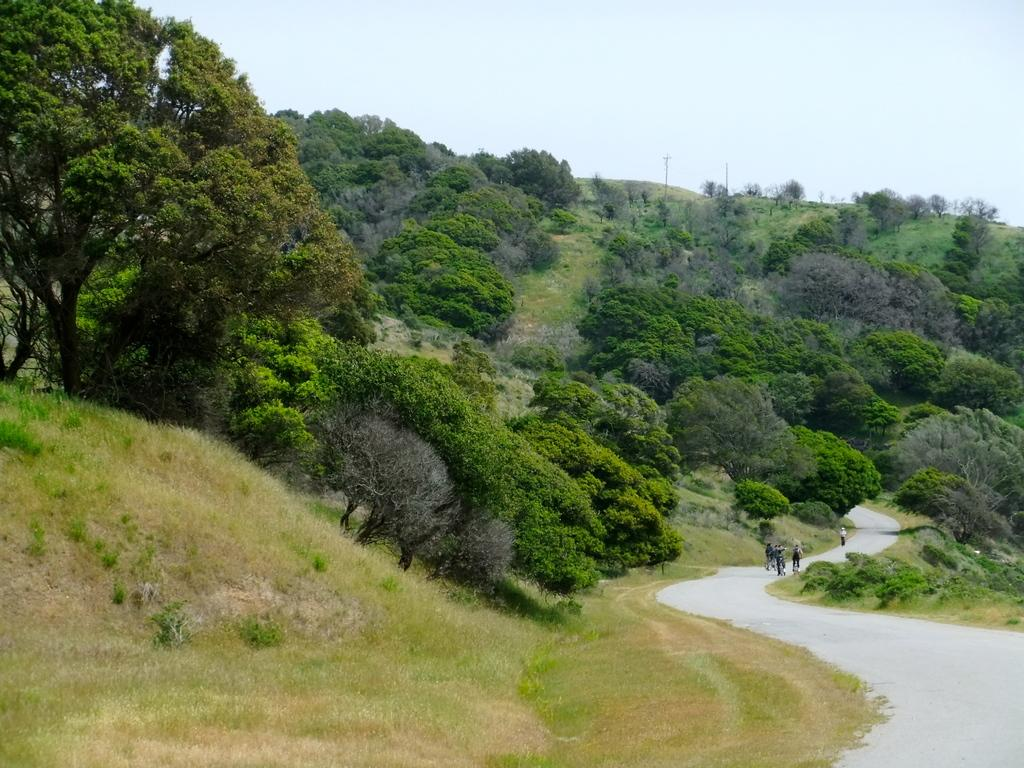What can be seen in the image involving multiple individuals? There is a group of people in the image. What type of vegetation is present in the image? There are trees with green color in the image. What are the tall, vertical structures in the image? There are poles in the image. What is the color of the sky in the image? The sky is blue and white in color. What type of vegetable is being harvested by the group of people in the image? There is no vegetable being harvested in the image; the group of people is not engaged in any activity related to vegetable harvesting. What type of silk material is draped over the trees in the image? There is no silk material present in the image; the trees have green leaves, but no silk is mentioned or visible. 